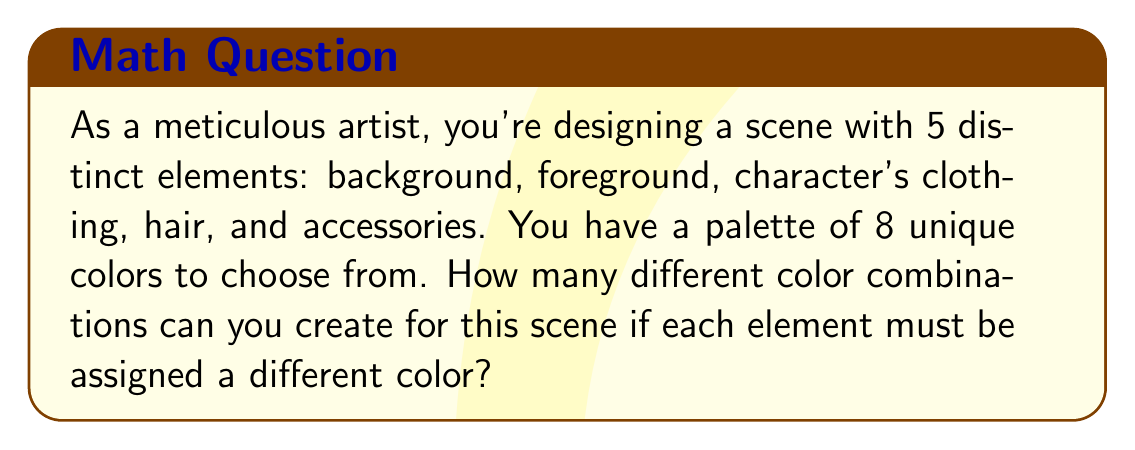Can you answer this question? Let's approach this step-by-step:

1) We need to choose 5 colors out of 8 for the 5 elements, where the order matters (as each color is assigned to a specific element).

2) This scenario is a perfect example of a permutation without repetition.

3) The formula for permutations without repetition is:

   $$P(n,r) = \frac{n!}{(n-r)!}$$

   Where $n$ is the total number of items to choose from, and $r$ is the number of items being chosen.

4) In this case, $n = 8$ (total colors) and $r = 5$ (elements to be colored).

5) Plugging these values into our formula:

   $$P(8,5) = \frac{8!}{(8-5)!} = \frac{8!}{3!}$$

6) Let's calculate this:
   
   $$\frac{8!}{3!} = \frac{8 \times 7 \times 6 \times 5 \times 4 \times 3!}{3!}$$

7) The $3!$ cancels out in the numerator and denominator:

   $$8 \times 7 \times 6 \times 5 \times 4 = 6720$$

Therefore, there are 6720 different ways to color the scene.
Answer: 6720 